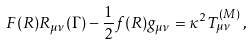Convert formula to latex. <formula><loc_0><loc_0><loc_500><loc_500>F ( R ) R _ { \mu \nu } ( \Gamma ) - \frac { 1 } { 2 } f ( R ) g _ { \mu \nu } = \kappa ^ { 2 } T _ { \mu \nu } ^ { ( M ) } \, ,</formula> 